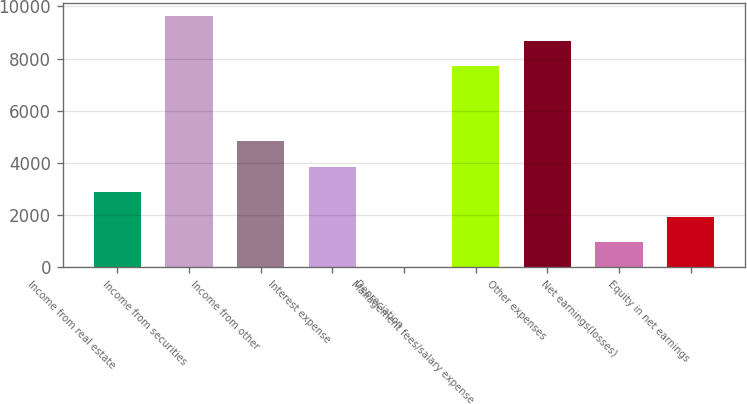<chart> <loc_0><loc_0><loc_500><loc_500><bar_chart><fcel>Income from real estate<fcel>Income from securities<fcel>Income from other<fcel>Interest expense<fcel>Depreciation<fcel>Management fees/salary expense<fcel>Other expenses<fcel>Net earnings(losses)<fcel>Equity in net earnings<nl><fcel>2903<fcel>9637<fcel>4827<fcel>3865<fcel>17<fcel>7713<fcel>8675<fcel>979<fcel>1941<nl></chart> 